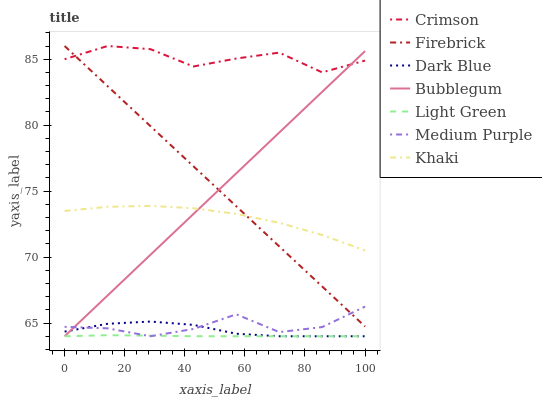Does Light Green have the minimum area under the curve?
Answer yes or no. Yes. Does Crimson have the maximum area under the curve?
Answer yes or no. Yes. Does Firebrick have the minimum area under the curve?
Answer yes or no. No. Does Firebrick have the maximum area under the curve?
Answer yes or no. No. Is Bubblegum the smoothest?
Answer yes or no. Yes. Is Crimson the roughest?
Answer yes or no. Yes. Is Firebrick the smoothest?
Answer yes or no. No. Is Firebrick the roughest?
Answer yes or no. No. Does Bubblegum have the lowest value?
Answer yes or no. Yes. Does Firebrick have the lowest value?
Answer yes or no. No. Does Crimson have the highest value?
Answer yes or no. Yes. Does Bubblegum have the highest value?
Answer yes or no. No. Is Dark Blue less than Khaki?
Answer yes or no. Yes. Is Crimson greater than Dark Blue?
Answer yes or no. Yes. Does Bubblegum intersect Khaki?
Answer yes or no. Yes. Is Bubblegum less than Khaki?
Answer yes or no. No. Is Bubblegum greater than Khaki?
Answer yes or no. No. Does Dark Blue intersect Khaki?
Answer yes or no. No. 